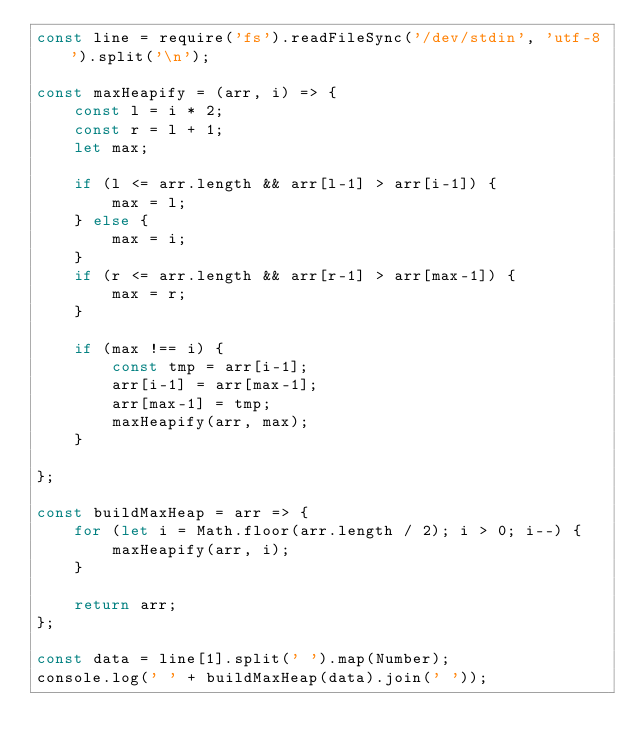<code> <loc_0><loc_0><loc_500><loc_500><_JavaScript_>const line = require('fs').readFileSync('/dev/stdin', 'utf-8').split('\n');

const maxHeapify = (arr, i) => {
    const l = i * 2;
    const r = l + 1;
    let max;

    if (l <= arr.length && arr[l-1] > arr[i-1]) {
        max = l;
    } else {
        max = i;
    }
    if (r <= arr.length && arr[r-1] > arr[max-1]) {
        max = r;
    }

    if (max !== i) {
        const tmp = arr[i-1];
        arr[i-1] = arr[max-1];
        arr[max-1] = tmp;
        maxHeapify(arr, max);
    }

};

const buildMaxHeap = arr => {
    for (let i = Math.floor(arr.length / 2); i > 0; i--) {
        maxHeapify(arr, i);
    }

    return arr;
};

const data = line[1].split(' ').map(Number);
console.log(' ' + buildMaxHeap(data).join(' '));

</code> 